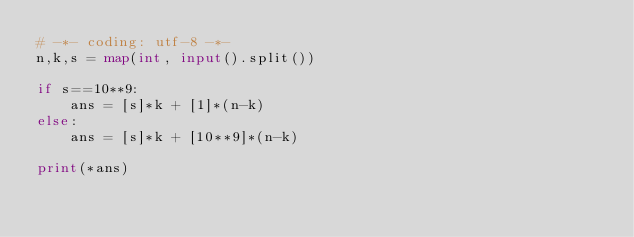<code> <loc_0><loc_0><loc_500><loc_500><_Python_># -*- coding: utf-8 -*-
n,k,s = map(int, input().split())

if s==10**9:
    ans = [s]*k + [1]*(n-k)
else:
    ans = [s]*k + [10**9]*(n-k)

print(*ans)</code> 